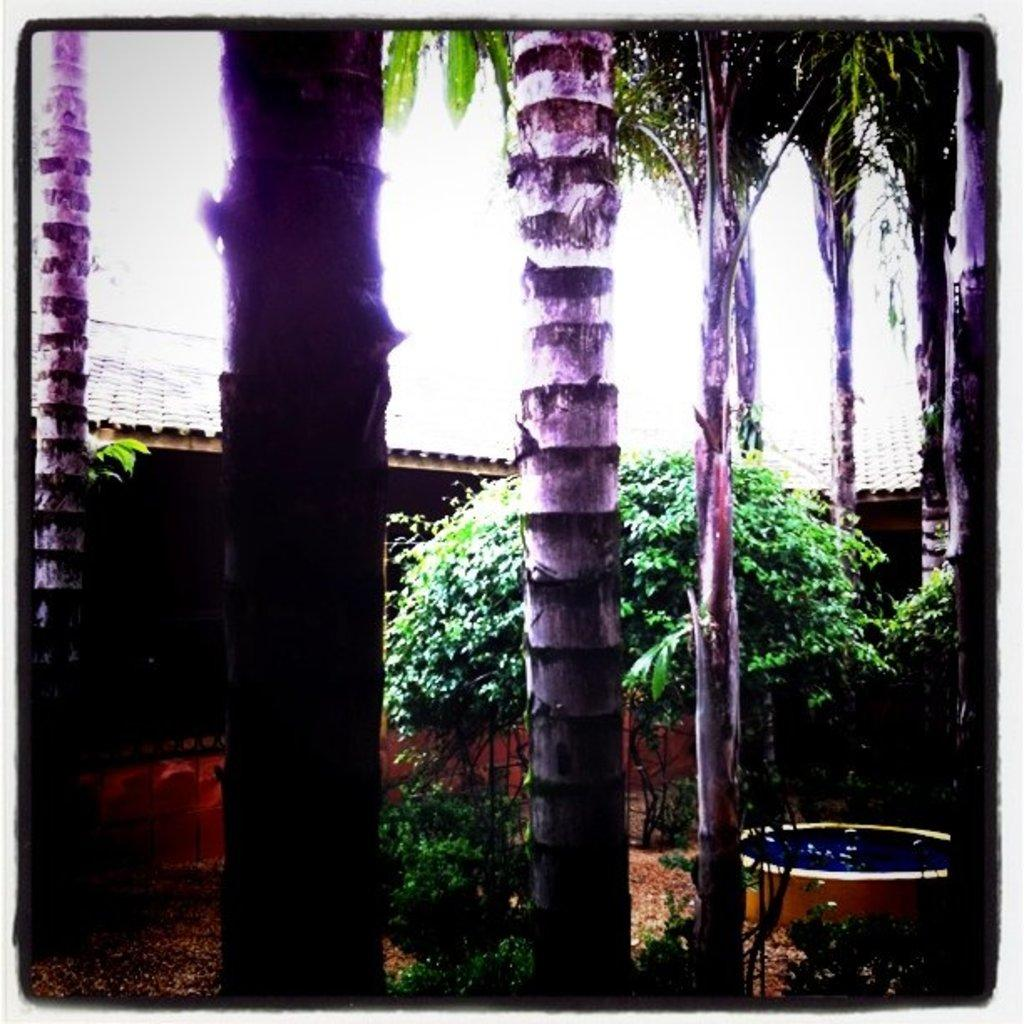What type of vegetation can be seen in the image? There are trees and plants in the image. What kind of water feature is present in the image? There is a small pool in the image. What type of structures can be seen in the image? There are sheds in the image. How many lawyers are present in the image? There are no lawyers present in the image. What type of planes can be seen flying over the trees in the image? There are no planes visible in the image. 